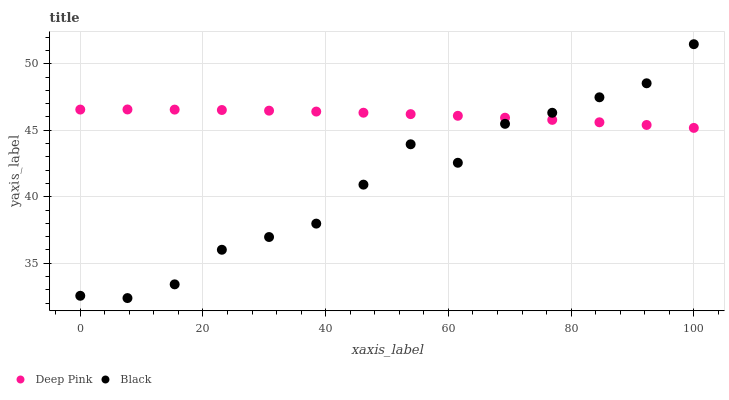Does Black have the minimum area under the curve?
Answer yes or no. Yes. Does Deep Pink have the maximum area under the curve?
Answer yes or no. Yes. Does Black have the maximum area under the curve?
Answer yes or no. No. Is Deep Pink the smoothest?
Answer yes or no. Yes. Is Black the roughest?
Answer yes or no. Yes. Is Black the smoothest?
Answer yes or no. No. Does Black have the lowest value?
Answer yes or no. Yes. Does Black have the highest value?
Answer yes or no. Yes. Does Deep Pink intersect Black?
Answer yes or no. Yes. Is Deep Pink less than Black?
Answer yes or no. No. Is Deep Pink greater than Black?
Answer yes or no. No. 